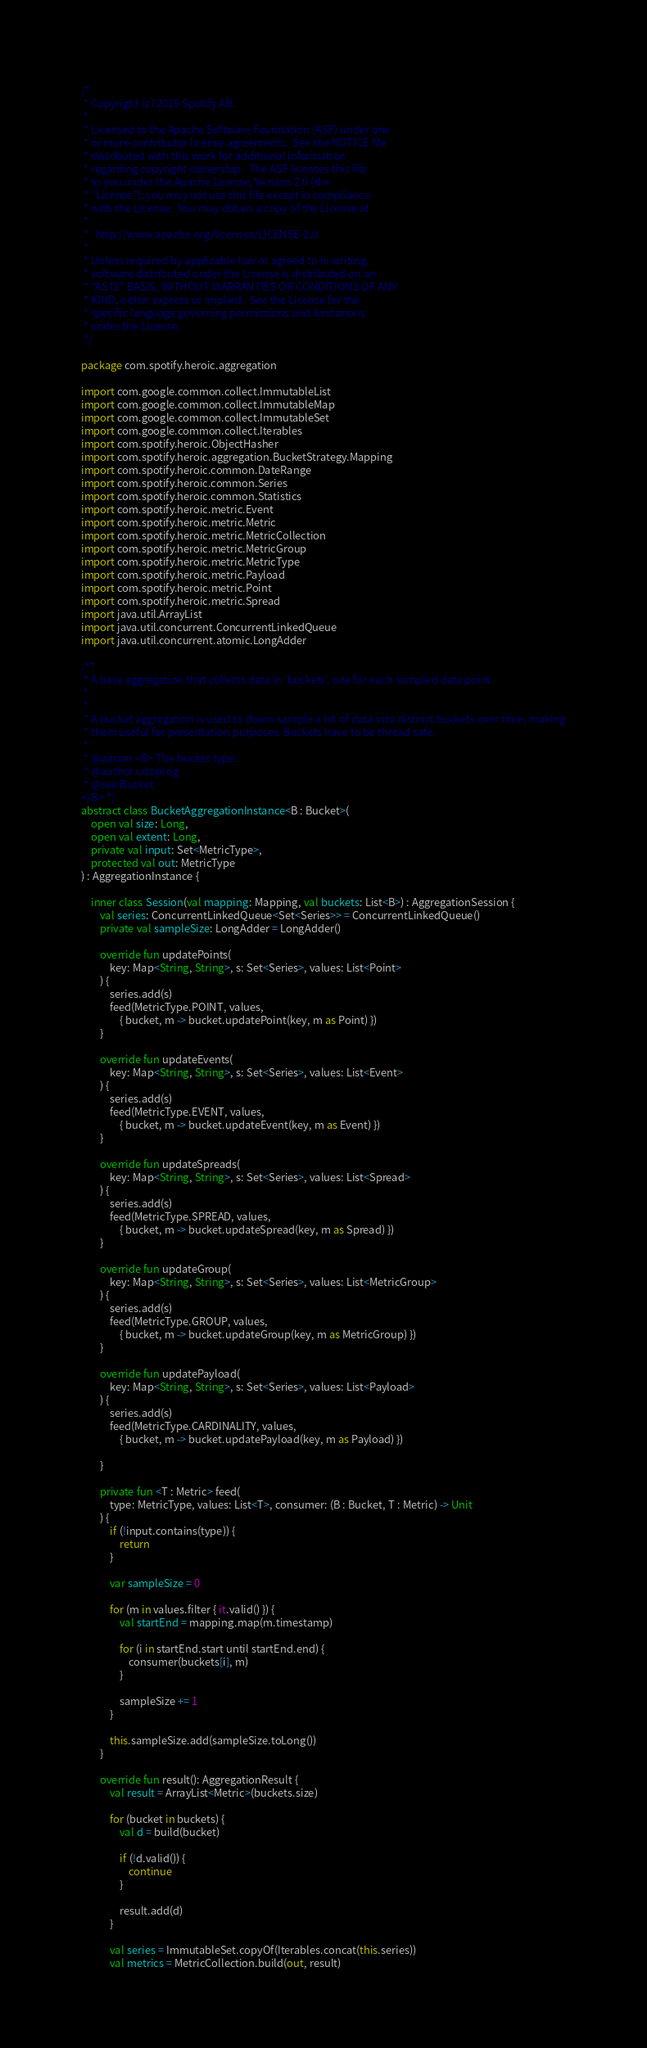<code> <loc_0><loc_0><loc_500><loc_500><_Kotlin_>/*
 * Copyright (c) 2019 Spotify AB.
 *
 * Licensed to the Apache Software Foundation (ASF) under one
 * or more contributor license agreements.  See the NOTICE file
 * distributed with this work for additional information
 * regarding copyright ownership.  The ASF licenses this file
 * to you under the Apache License, Version 2.0 (the
 * "License"); you may not use this file except in compliance
 * with the License.  You may obtain a copy of the License at
 *
 *   http://www.apache.org/licenses/LICENSE-2.0
 *
 * Unless required by applicable law or agreed to in writing,
 * software distributed under the License is distributed on an
 * "AS IS" BASIS, WITHOUT WARRANTIES OR CONDITIONS OF ANY
 * KIND, either express or implied.  See the License for the
 * specific language governing permissions and limitations
 * under the License.
 */

package com.spotify.heroic.aggregation

import com.google.common.collect.ImmutableList
import com.google.common.collect.ImmutableMap
import com.google.common.collect.ImmutableSet
import com.google.common.collect.Iterables
import com.spotify.heroic.ObjectHasher
import com.spotify.heroic.aggregation.BucketStrategy.Mapping
import com.spotify.heroic.common.DateRange
import com.spotify.heroic.common.Series
import com.spotify.heroic.common.Statistics
import com.spotify.heroic.metric.Event
import com.spotify.heroic.metric.Metric
import com.spotify.heroic.metric.MetricCollection
import com.spotify.heroic.metric.MetricGroup
import com.spotify.heroic.metric.MetricType
import com.spotify.heroic.metric.Payload
import com.spotify.heroic.metric.Point
import com.spotify.heroic.metric.Spread
import java.util.ArrayList
import java.util.concurrent.ConcurrentLinkedQueue
import java.util.concurrent.atomic.LongAdder

/**
 * A base aggregation that collects data in 'buckets', one for each sampled data point.
 *
 *
 * A bucket aggregation is used to down-sample a lot of data into distinct buckets over time, making
 * them useful for presentation purposes. Buckets have to be thread safe.
 *
 * @param <B> The bucket type.
 * @author udoprog
 * @see Bucket
</B> */
abstract class BucketAggregationInstance<B : Bucket>(
    open val size: Long,
    open val extent: Long,
    private val input: Set<MetricType>,
    protected val out: MetricType
) : AggregationInstance {

    inner class Session(val mapping: Mapping, val buckets: List<B>) : AggregationSession {
        val series: ConcurrentLinkedQueue<Set<Series>> = ConcurrentLinkedQueue()
        private val sampleSize: LongAdder = LongAdder()

        override fun updatePoints(
            key: Map<String, String>, s: Set<Series>, values: List<Point>
        ) {
            series.add(s)
            feed(MetricType.POINT, values,
                { bucket, m -> bucket.updatePoint(key, m as Point) })
        }

        override fun updateEvents(
            key: Map<String, String>, s: Set<Series>, values: List<Event>
        ) {
            series.add(s)
            feed(MetricType.EVENT, values,
                { bucket, m -> bucket.updateEvent(key, m as Event) })
        }

        override fun updateSpreads(
            key: Map<String, String>, s: Set<Series>, values: List<Spread>
        ) {
            series.add(s)
            feed(MetricType.SPREAD, values,
                { bucket, m -> bucket.updateSpread(key, m as Spread) })
        }

        override fun updateGroup(
            key: Map<String, String>, s: Set<Series>, values: List<MetricGroup>
        ) {
            series.add(s)
            feed(MetricType.GROUP, values,
                { bucket, m -> bucket.updateGroup(key, m as MetricGroup) })
        }

        override fun updatePayload(
            key: Map<String, String>, s: Set<Series>, values: List<Payload>
        ) {
            series.add(s)
            feed(MetricType.CARDINALITY, values,
                { bucket, m -> bucket.updatePayload(key, m as Payload) })

        }

        private fun <T : Metric> feed(
            type: MetricType, values: List<T>, consumer: (B : Bucket, T : Metric) -> Unit
        ) {
            if (!input.contains(type)) {
                return
            }

            var sampleSize = 0

            for (m in values.filter { it.valid() }) {
                val startEnd = mapping.map(m.timestamp)

                for (i in startEnd.start until startEnd.end) {
                    consumer(buckets[i], m)
                }

                sampleSize += 1
            }

            this.sampleSize.add(sampleSize.toLong())
        }

        override fun result(): AggregationResult {
            val result = ArrayList<Metric>(buckets.size)

            for (bucket in buckets) {
                val d = build(bucket)

                if (!d.valid()) {
                    continue
                }

                result.add(d)
            }

            val series = ImmutableSet.copyOf(Iterables.concat(this.series))
            val metrics = MetricCollection.build(out, result)
</code> 